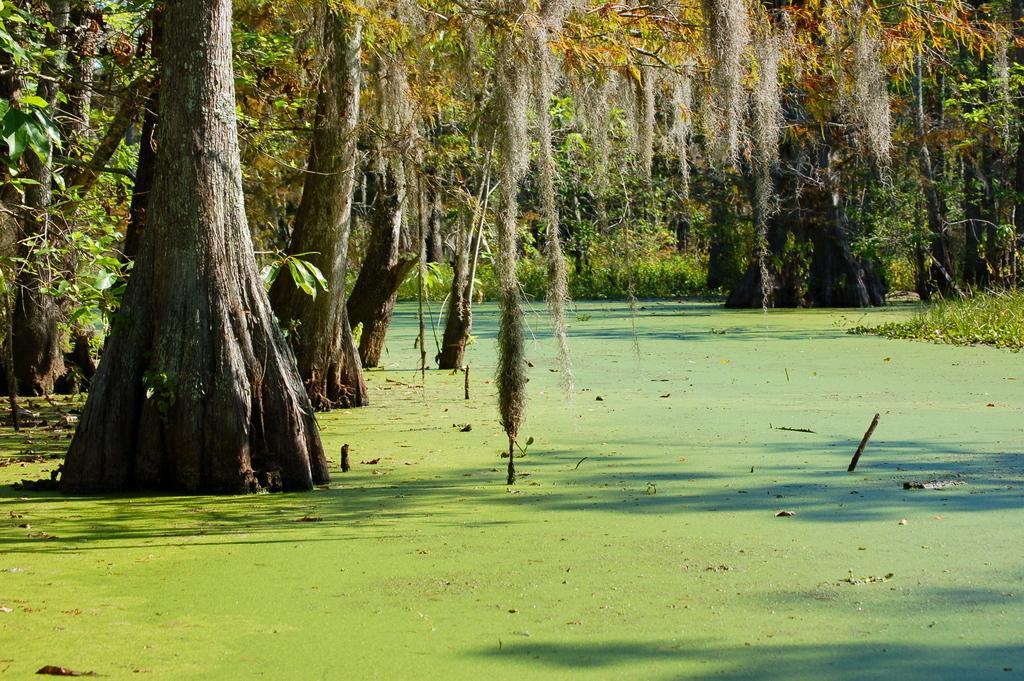How would you summarize this image in a sentence or two? There are many trees and grass around the green surface. 